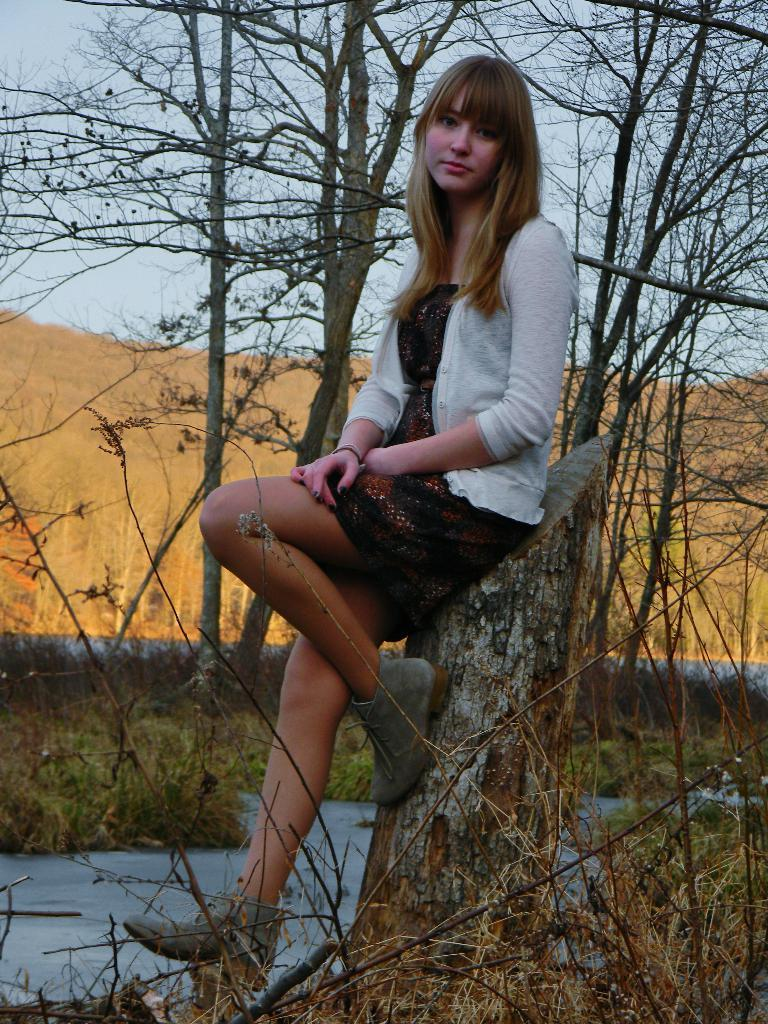What is the woman in the image sitting on? The woman is sitting on the trunk in the image. What type of vegetation can be seen in the image? There is green grass visible in the image. What else is present in the image besides the woman and the trunk? There are trees in the image. What can be seen in the sky in the image? Clouds are present in the sky in the image. What type of desk is visible in the image? There is no desk present in the image. How many fingers does the woman have on her right hand in the image? The number of fingers on the woman's right hand cannot be determined from the image, as her hands are not visible. 